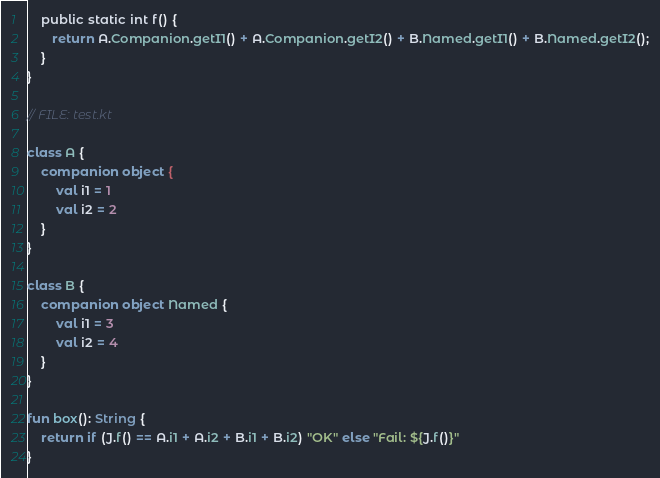<code> <loc_0><loc_0><loc_500><loc_500><_Kotlin_>    public static int f() {
       return A.Companion.getI1() + A.Companion.getI2() + B.Named.getI1() + B.Named.getI2();
    }
}

// FILE: test.kt

class A {
    companion object {
        val i1 = 1
        val i2 = 2
    }
}

class B {
    companion object Named {
        val i1 = 3
        val i2 = 4
    }
}

fun box(): String {
    return if (J.f() == A.i1 + A.i2 + B.i1 + B.i2) "OK" else "Fail: ${J.f()}"
}
</code> 